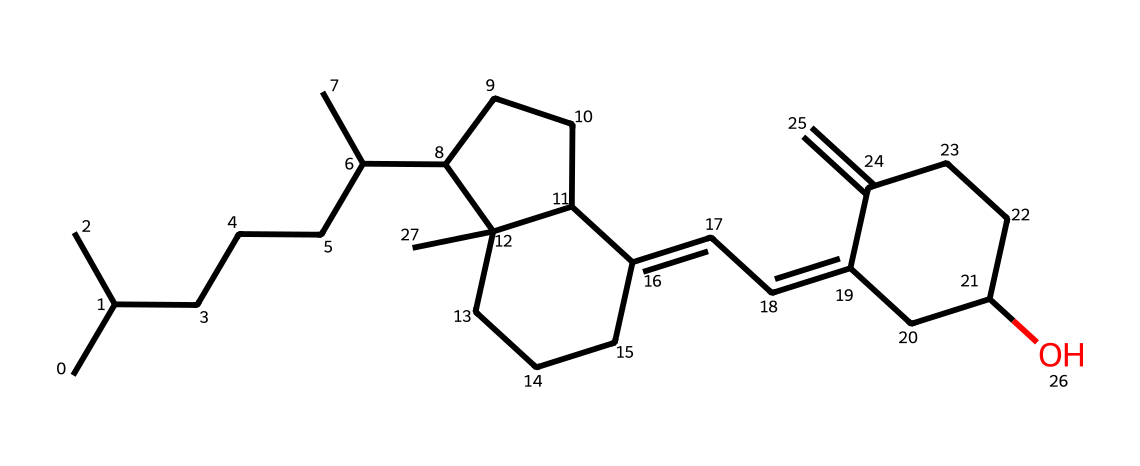What is the molecular formula of this vitamin D3 compound? To determine the molecular formula, we count the number of carbon (C), hydrogen (H), and oxygen (O) atoms present in the SMILES. The structure indicates 27 carbon atoms, 44 hydrogen atoms, and 1 oxygen atom. Thus, the molecular formula is C27H44O.
Answer: C27H44O How many rings are present in the structure of vitamin D3? By analyzing the structure represented in the SMILES notation, we can identify that there are three distinct cyclic components, confirming the presence of three rings.
Answer: 3 What type of vitamin is represented by this chemical structure? The structure indicates that it is a form of vitamin D, specifically vitamin D3 (cholecalciferol), which is essential for calcium homeostasis and bone health.
Answer: vitamin D3 Which functional group is present in this vitamin D3 molecule? In the structure, we can observe a hydroxyl group (-OH) attached to the carbon skeleton, which identifies the molecule as a steroid-type compound with a relevant functional group.
Answer: hydroxyl What property of vitamin D3 is reflected by its structure? The presence of long carbon chains and cyclic rings in the structure impart lipophilicity, indicating that vitamin D3 is fat-soluble, which is critical for its biological function.
Answer: fat-soluble How does the presence of the hydroxyl group affect vitamin D3? The hydroxyl group contributes to the hydrophilic character of the molecule, enhancing its solubility in biological systems which helps facilitate its transport and function in the body.
Answer: enhances solubility 